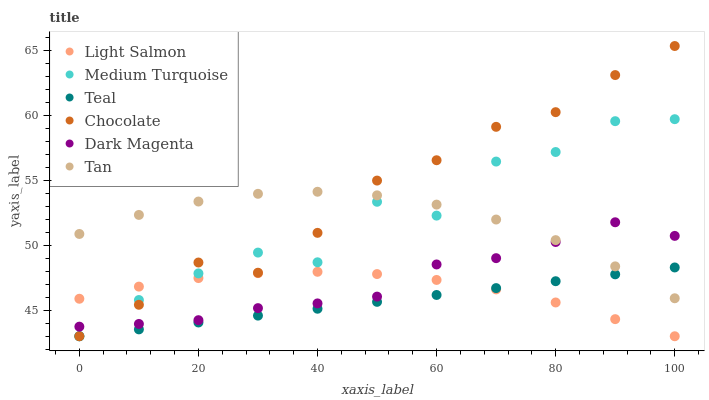Does Teal have the minimum area under the curve?
Answer yes or no. Yes. Does Chocolate have the maximum area under the curve?
Answer yes or no. Yes. Does Dark Magenta have the minimum area under the curve?
Answer yes or no. No. Does Dark Magenta have the maximum area under the curve?
Answer yes or no. No. Is Teal the smoothest?
Answer yes or no. Yes. Is Medium Turquoise the roughest?
Answer yes or no. Yes. Is Dark Magenta the smoothest?
Answer yes or no. No. Is Dark Magenta the roughest?
Answer yes or no. No. Does Light Salmon have the lowest value?
Answer yes or no. Yes. Does Dark Magenta have the lowest value?
Answer yes or no. No. Does Chocolate have the highest value?
Answer yes or no. Yes. Does Dark Magenta have the highest value?
Answer yes or no. No. Is Teal less than Dark Magenta?
Answer yes or no. Yes. Is Dark Magenta greater than Teal?
Answer yes or no. Yes. Does Dark Magenta intersect Medium Turquoise?
Answer yes or no. Yes. Is Dark Magenta less than Medium Turquoise?
Answer yes or no. No. Is Dark Magenta greater than Medium Turquoise?
Answer yes or no. No. Does Teal intersect Dark Magenta?
Answer yes or no. No. 